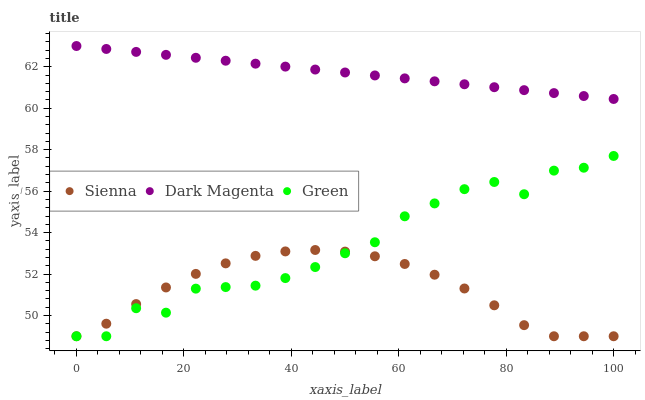Does Sienna have the minimum area under the curve?
Answer yes or no. Yes. Does Dark Magenta have the maximum area under the curve?
Answer yes or no. Yes. Does Green have the minimum area under the curve?
Answer yes or no. No. Does Green have the maximum area under the curve?
Answer yes or no. No. Is Dark Magenta the smoothest?
Answer yes or no. Yes. Is Green the roughest?
Answer yes or no. Yes. Is Green the smoothest?
Answer yes or no. No. Is Dark Magenta the roughest?
Answer yes or no. No. Does Sienna have the lowest value?
Answer yes or no. Yes. Does Dark Magenta have the lowest value?
Answer yes or no. No. Does Dark Magenta have the highest value?
Answer yes or no. Yes. Does Green have the highest value?
Answer yes or no. No. Is Green less than Dark Magenta?
Answer yes or no. Yes. Is Dark Magenta greater than Sienna?
Answer yes or no. Yes. Does Green intersect Sienna?
Answer yes or no. Yes. Is Green less than Sienna?
Answer yes or no. No. Is Green greater than Sienna?
Answer yes or no. No. Does Green intersect Dark Magenta?
Answer yes or no. No. 